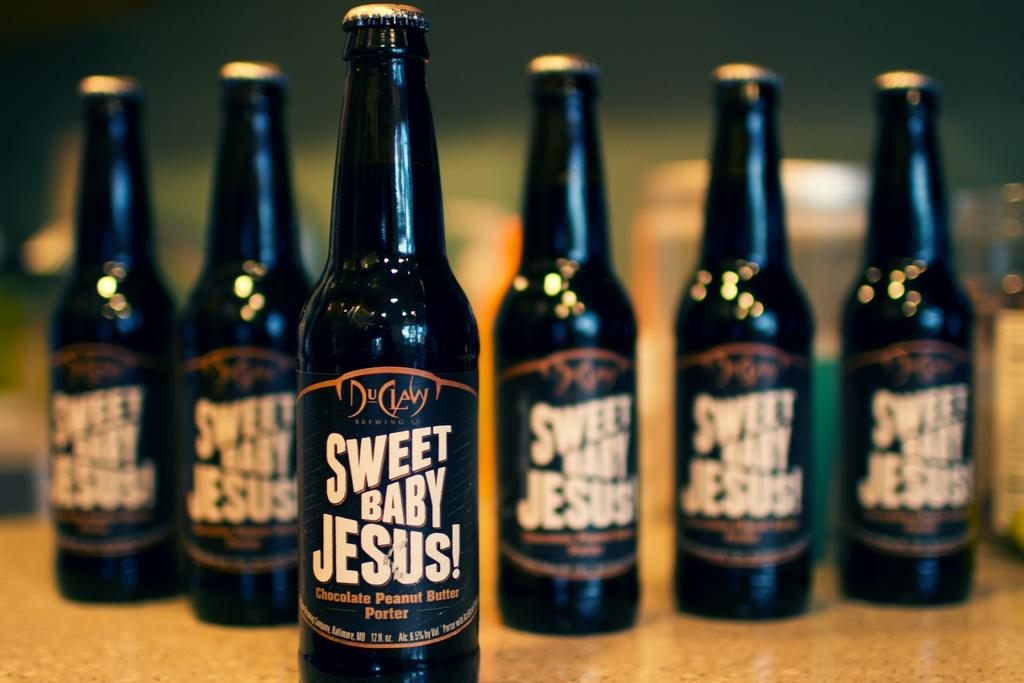<image>
Summarize the visual content of the image. Six bottles of Sweet Baby Jesus! beer in a line with one out front. 